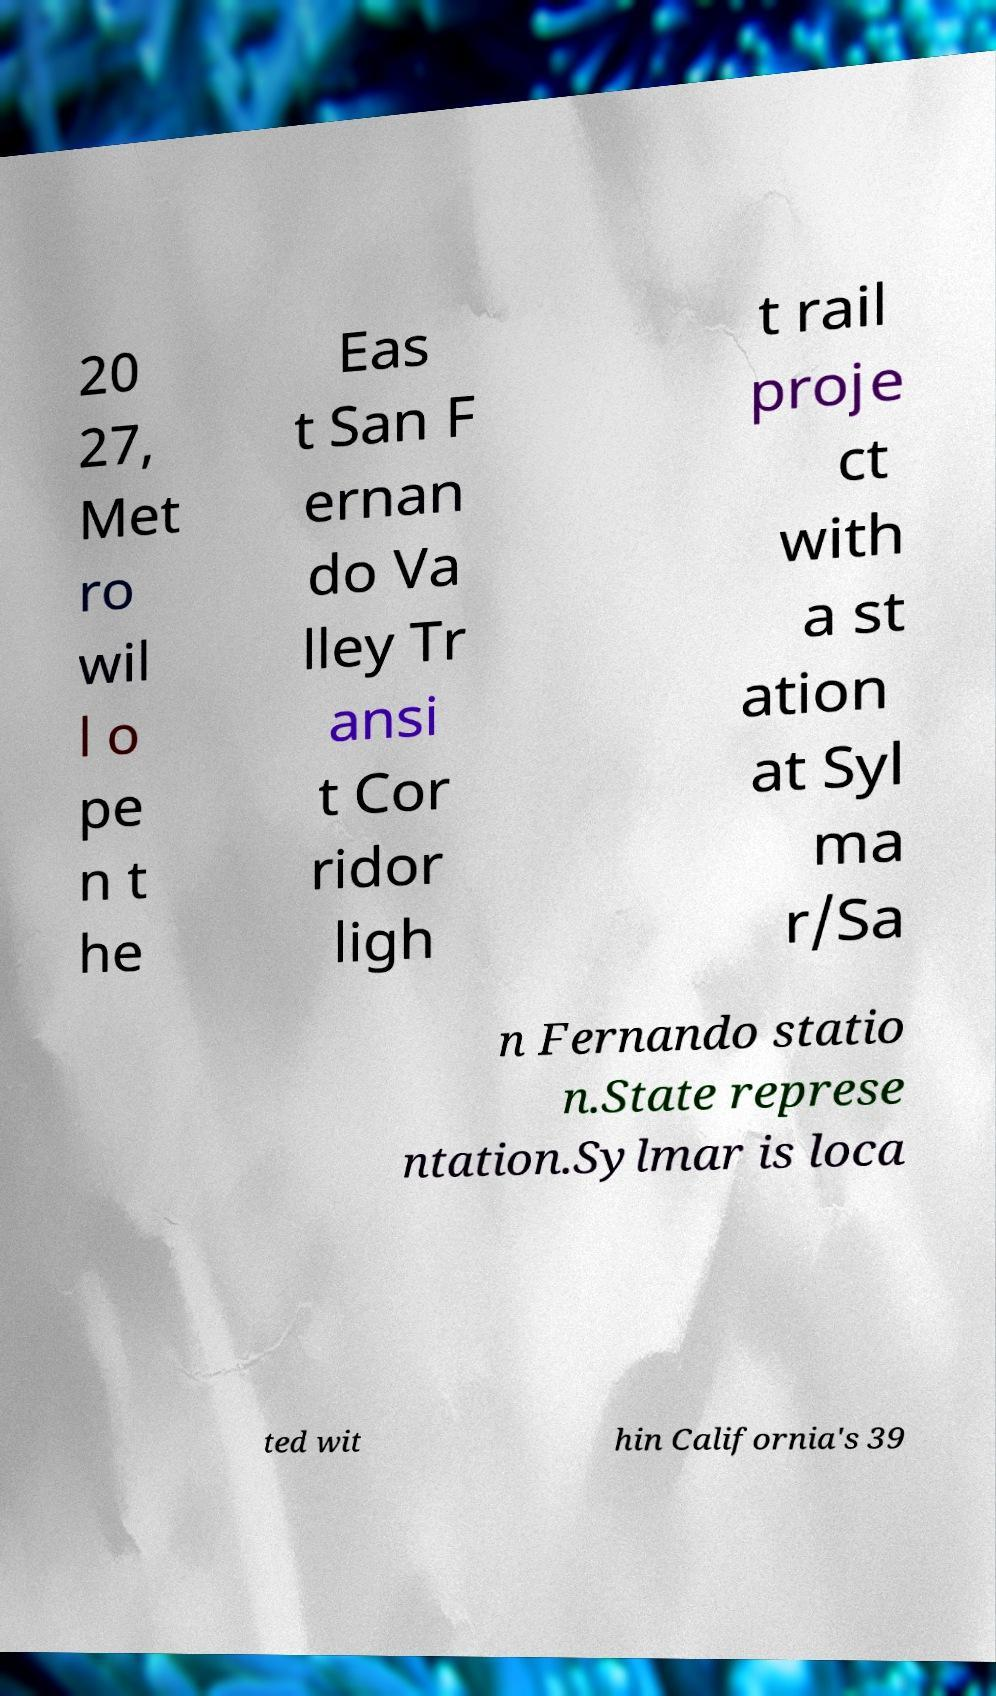Can you accurately transcribe the text from the provided image for me? 20 27, Met ro wil l o pe n t he Eas t San F ernan do Va lley Tr ansi t Cor ridor ligh t rail proje ct with a st ation at Syl ma r/Sa n Fernando statio n.State represe ntation.Sylmar is loca ted wit hin California's 39 